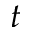<formula> <loc_0><loc_0><loc_500><loc_500>t</formula> 